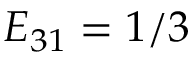Convert formula to latex. <formula><loc_0><loc_0><loc_500><loc_500>E _ { 3 1 } = 1 / 3</formula> 